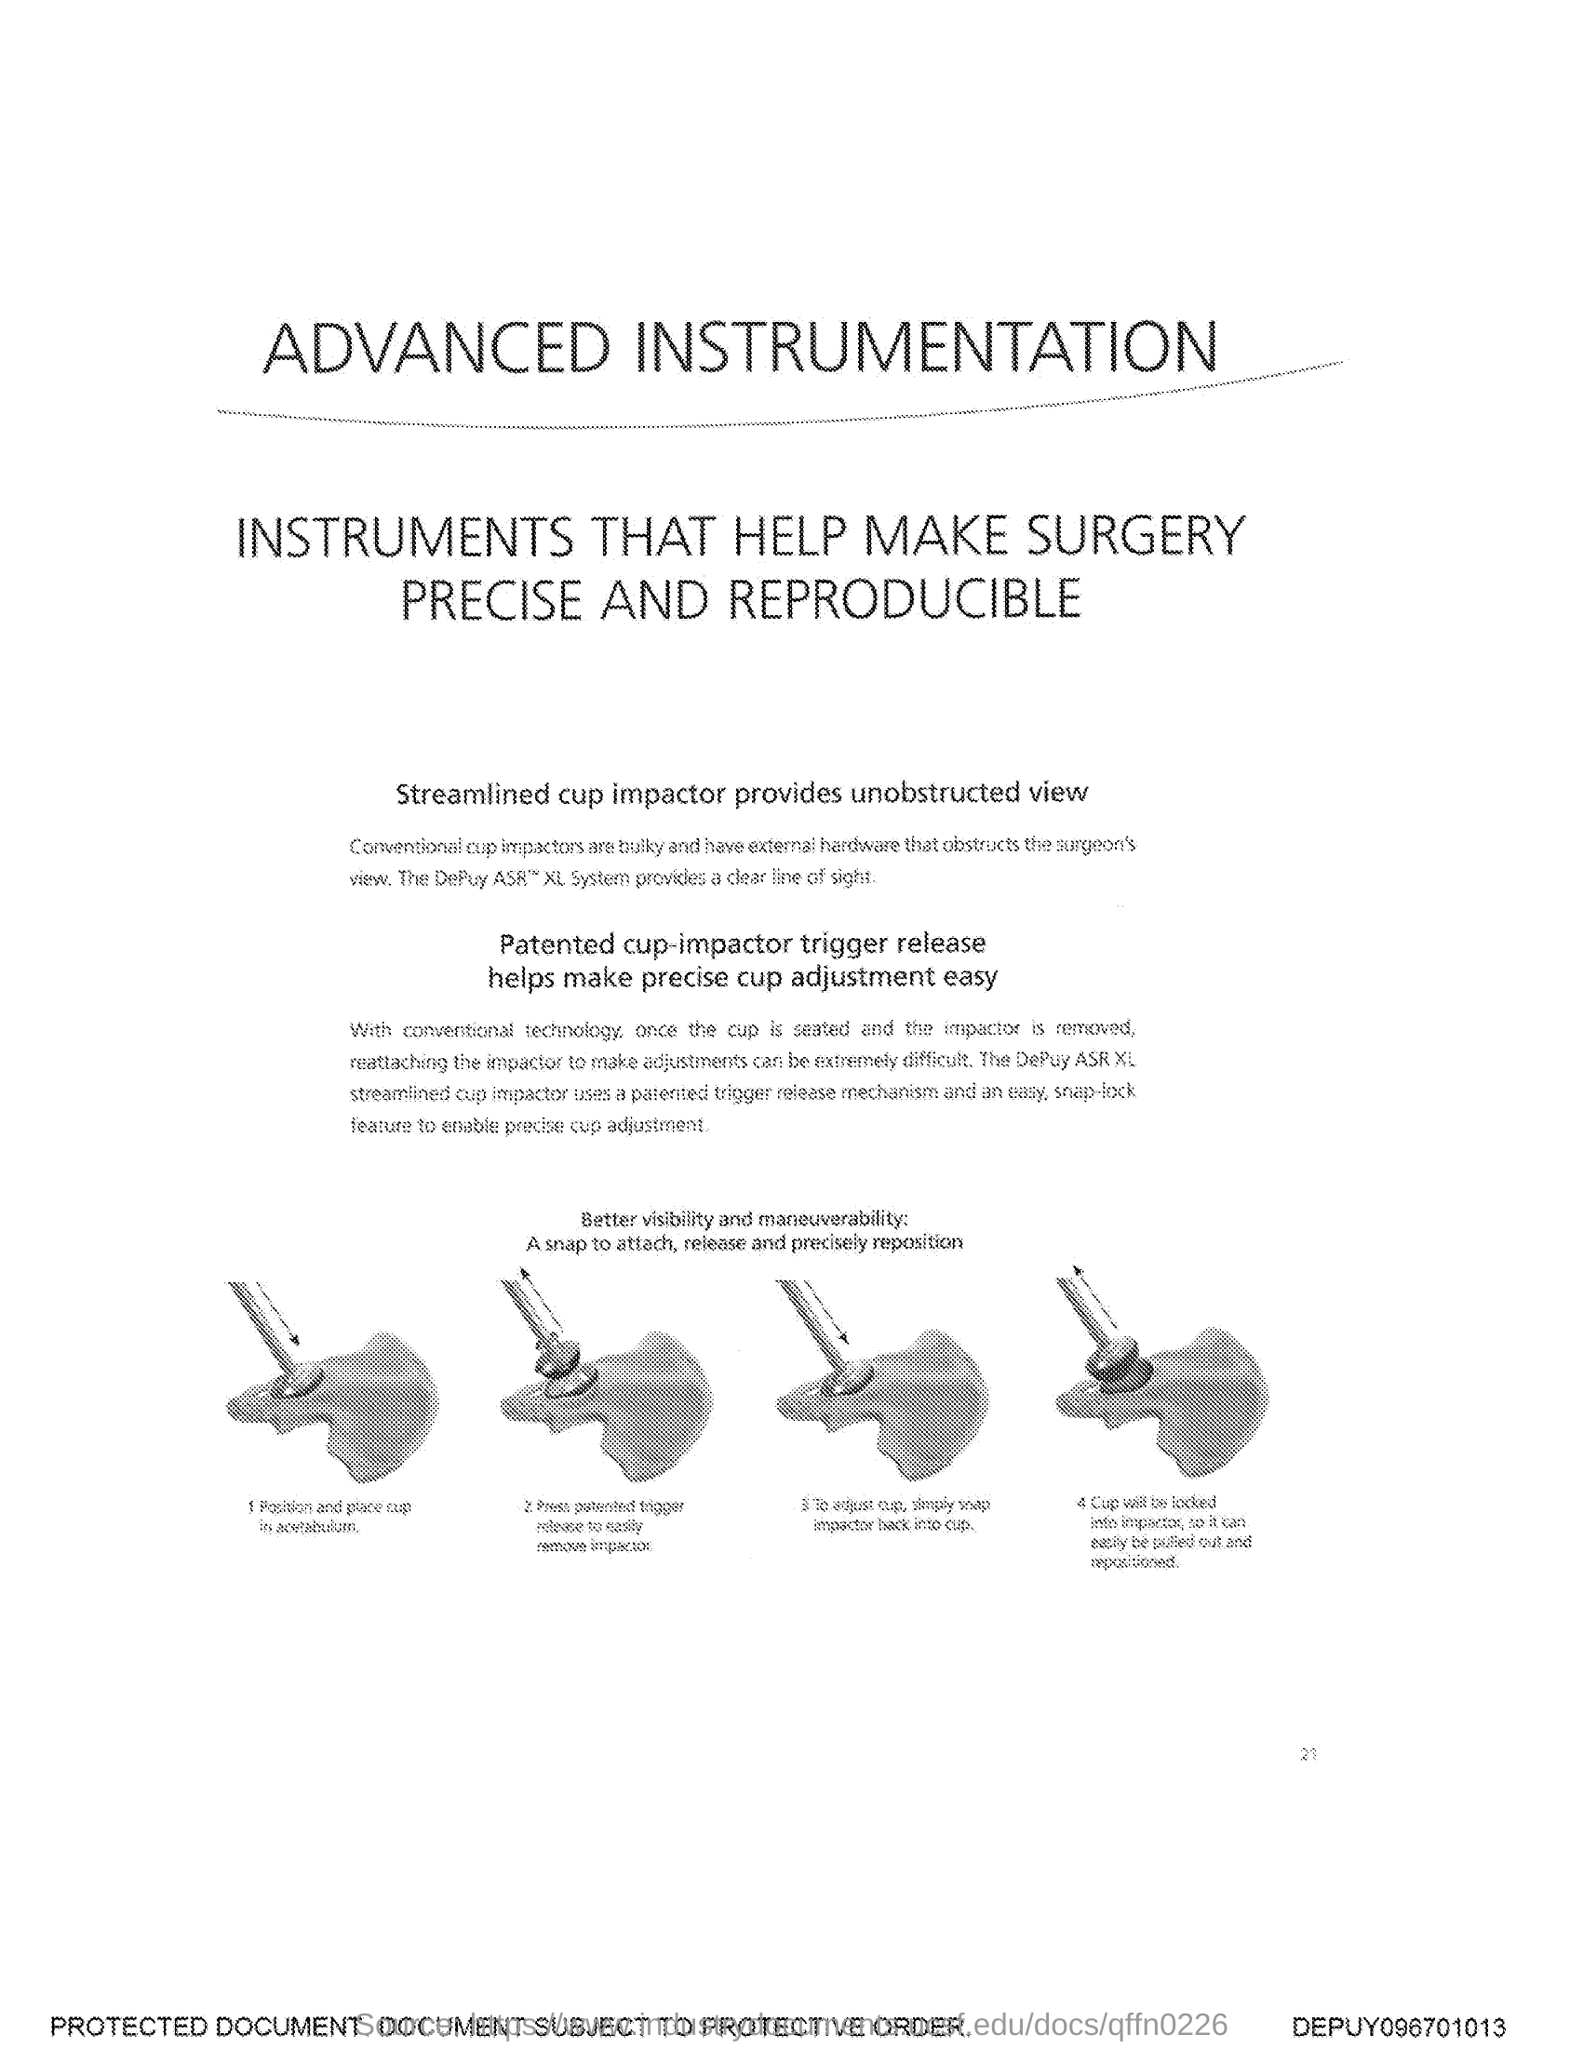List a handful of essential elements in this visual. The number at the bottom of the page is 21. 